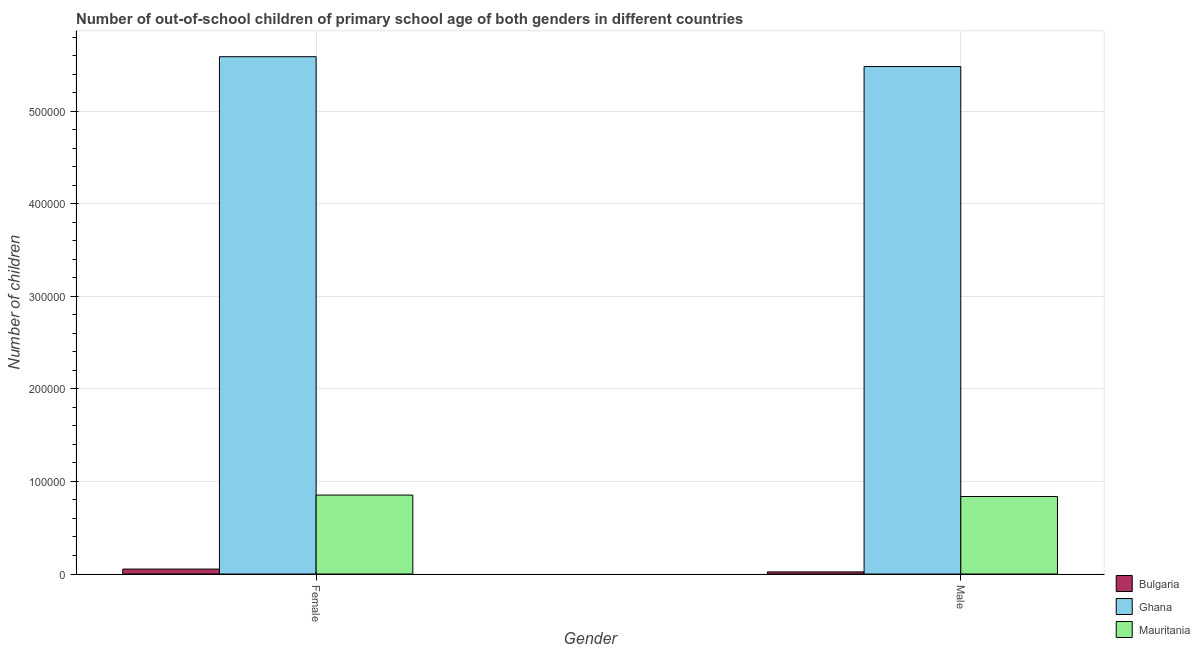How many bars are there on the 1st tick from the left?
Provide a short and direct response. 3. How many bars are there on the 1st tick from the right?
Your answer should be very brief. 3. What is the number of male out-of-school students in Bulgaria?
Your answer should be very brief. 2280. Across all countries, what is the maximum number of female out-of-school students?
Your response must be concise. 5.59e+05. Across all countries, what is the minimum number of female out-of-school students?
Offer a very short reply. 5332. What is the total number of male out-of-school students in the graph?
Your answer should be very brief. 6.34e+05. What is the difference between the number of male out-of-school students in Mauritania and that in Bulgaria?
Your answer should be compact. 8.15e+04. What is the difference between the number of male out-of-school students in Ghana and the number of female out-of-school students in Mauritania?
Your answer should be very brief. 4.63e+05. What is the average number of male out-of-school students per country?
Keep it short and to the point. 2.11e+05. What is the difference between the number of male out-of-school students and number of female out-of-school students in Ghana?
Your answer should be very brief. -1.06e+04. What is the ratio of the number of male out-of-school students in Bulgaria to that in Mauritania?
Make the answer very short. 0.03. How many bars are there?
Provide a short and direct response. 6. Are all the bars in the graph horizontal?
Offer a very short reply. No. How many countries are there in the graph?
Offer a terse response. 3. What is the difference between two consecutive major ticks on the Y-axis?
Your response must be concise. 1.00e+05. Are the values on the major ticks of Y-axis written in scientific E-notation?
Make the answer very short. No. Where does the legend appear in the graph?
Ensure brevity in your answer.  Bottom right. How many legend labels are there?
Your answer should be very brief. 3. How are the legend labels stacked?
Give a very brief answer. Vertical. What is the title of the graph?
Make the answer very short. Number of out-of-school children of primary school age of both genders in different countries. Does "West Bank and Gaza" appear as one of the legend labels in the graph?
Make the answer very short. No. What is the label or title of the Y-axis?
Your response must be concise. Number of children. What is the Number of children of Bulgaria in Female?
Ensure brevity in your answer.  5332. What is the Number of children in Ghana in Female?
Your answer should be compact. 5.59e+05. What is the Number of children of Mauritania in Female?
Keep it short and to the point. 8.53e+04. What is the Number of children in Bulgaria in Male?
Ensure brevity in your answer.  2280. What is the Number of children in Ghana in Male?
Make the answer very short. 5.48e+05. What is the Number of children of Mauritania in Male?
Keep it short and to the point. 8.38e+04. Across all Gender, what is the maximum Number of children in Bulgaria?
Keep it short and to the point. 5332. Across all Gender, what is the maximum Number of children in Ghana?
Offer a very short reply. 5.59e+05. Across all Gender, what is the maximum Number of children in Mauritania?
Ensure brevity in your answer.  8.53e+04. Across all Gender, what is the minimum Number of children of Bulgaria?
Your answer should be compact. 2280. Across all Gender, what is the minimum Number of children of Ghana?
Your answer should be very brief. 5.48e+05. Across all Gender, what is the minimum Number of children in Mauritania?
Provide a short and direct response. 8.38e+04. What is the total Number of children of Bulgaria in the graph?
Keep it short and to the point. 7612. What is the total Number of children in Ghana in the graph?
Your answer should be compact. 1.11e+06. What is the total Number of children of Mauritania in the graph?
Your answer should be very brief. 1.69e+05. What is the difference between the Number of children of Bulgaria in Female and that in Male?
Provide a succinct answer. 3052. What is the difference between the Number of children in Ghana in Female and that in Male?
Keep it short and to the point. 1.06e+04. What is the difference between the Number of children of Mauritania in Female and that in Male?
Provide a succinct answer. 1543. What is the difference between the Number of children of Bulgaria in Female and the Number of children of Ghana in Male?
Provide a succinct answer. -5.43e+05. What is the difference between the Number of children in Bulgaria in Female and the Number of children in Mauritania in Male?
Give a very brief answer. -7.84e+04. What is the difference between the Number of children in Ghana in Female and the Number of children in Mauritania in Male?
Your response must be concise. 4.75e+05. What is the average Number of children of Bulgaria per Gender?
Your answer should be very brief. 3806. What is the average Number of children of Ghana per Gender?
Offer a terse response. 5.54e+05. What is the average Number of children in Mauritania per Gender?
Your answer should be very brief. 8.45e+04. What is the difference between the Number of children in Bulgaria and Number of children in Ghana in Female?
Provide a succinct answer. -5.54e+05. What is the difference between the Number of children of Bulgaria and Number of children of Mauritania in Female?
Provide a succinct answer. -8.00e+04. What is the difference between the Number of children in Ghana and Number of children in Mauritania in Female?
Your answer should be compact. 4.74e+05. What is the difference between the Number of children in Bulgaria and Number of children in Ghana in Male?
Keep it short and to the point. -5.46e+05. What is the difference between the Number of children in Bulgaria and Number of children in Mauritania in Male?
Keep it short and to the point. -8.15e+04. What is the difference between the Number of children of Ghana and Number of children of Mauritania in Male?
Give a very brief answer. 4.65e+05. What is the ratio of the Number of children in Bulgaria in Female to that in Male?
Your answer should be very brief. 2.34. What is the ratio of the Number of children in Ghana in Female to that in Male?
Give a very brief answer. 1.02. What is the ratio of the Number of children in Mauritania in Female to that in Male?
Your answer should be very brief. 1.02. What is the difference between the highest and the second highest Number of children of Bulgaria?
Make the answer very short. 3052. What is the difference between the highest and the second highest Number of children of Ghana?
Give a very brief answer. 1.06e+04. What is the difference between the highest and the second highest Number of children of Mauritania?
Provide a short and direct response. 1543. What is the difference between the highest and the lowest Number of children in Bulgaria?
Offer a very short reply. 3052. What is the difference between the highest and the lowest Number of children of Ghana?
Your answer should be compact. 1.06e+04. What is the difference between the highest and the lowest Number of children of Mauritania?
Your answer should be compact. 1543. 